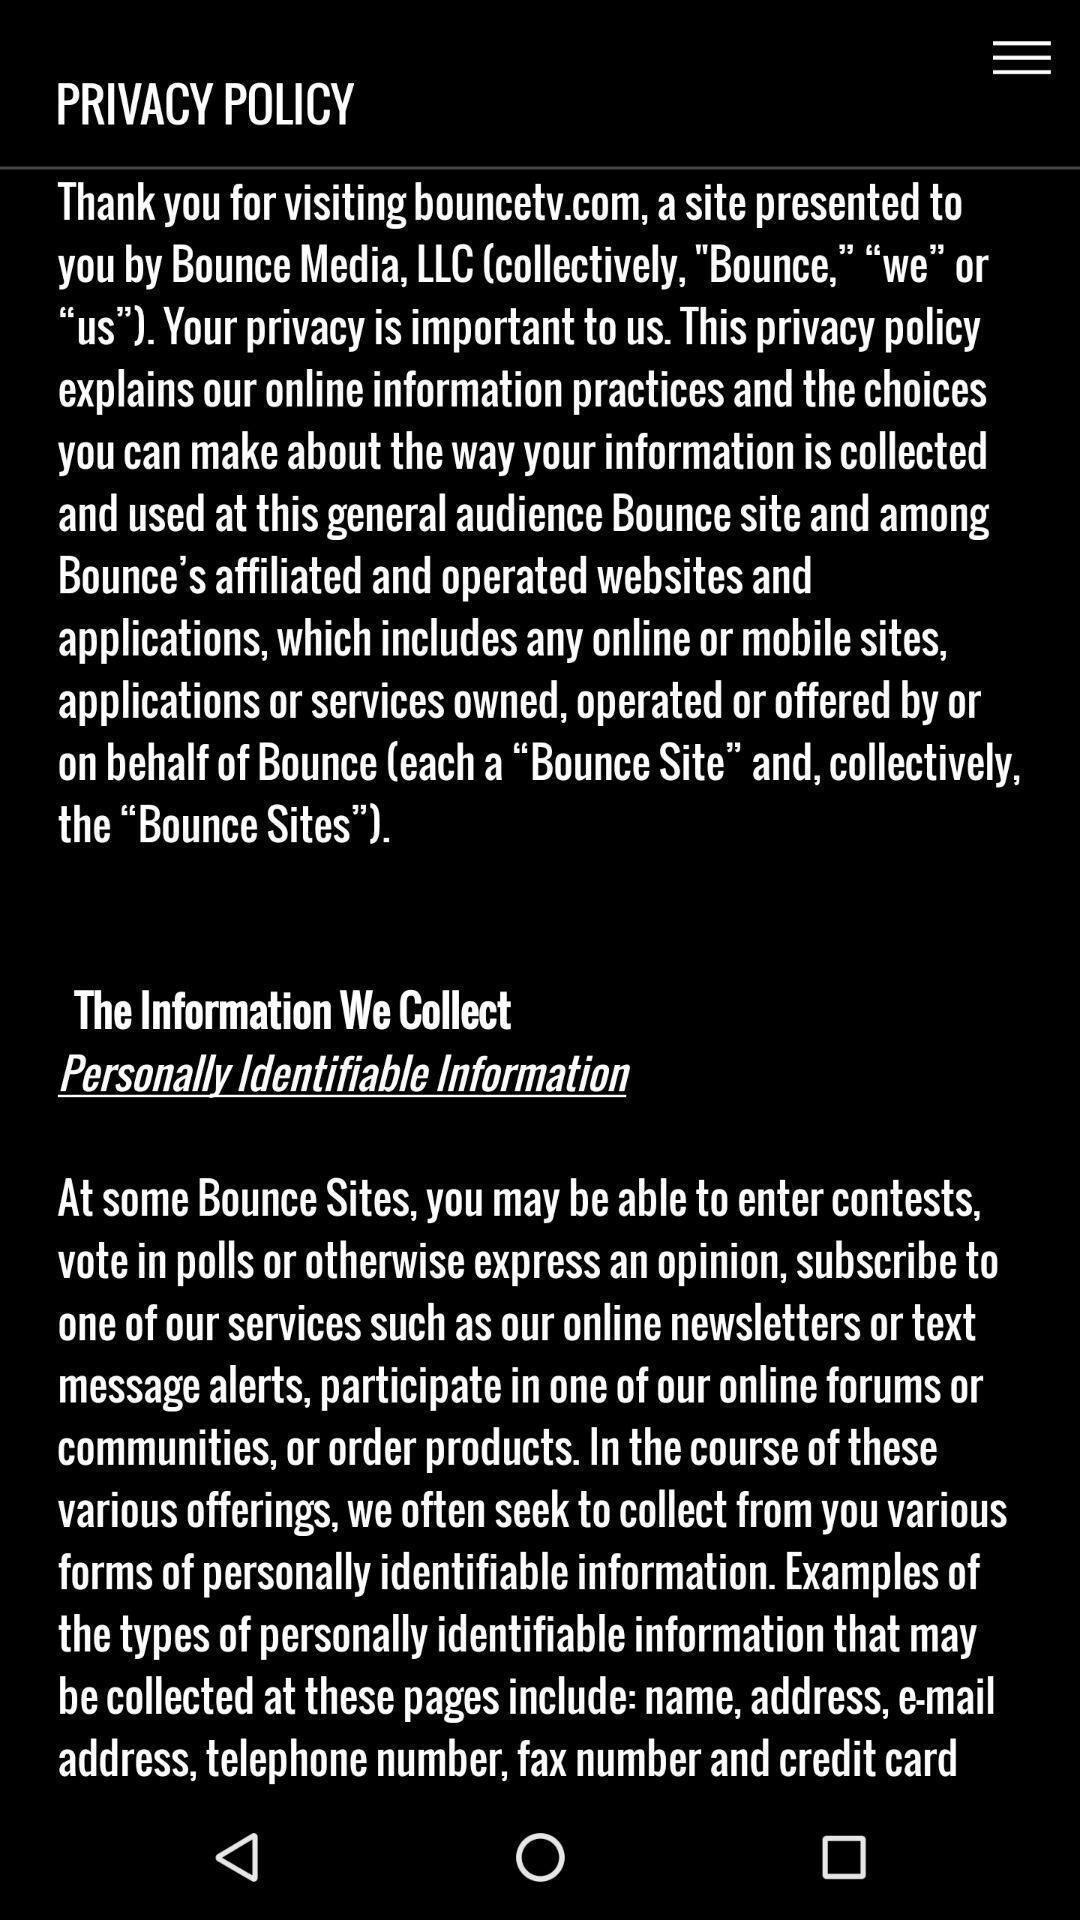Describe the key features of this screenshot. Screen displaying policies information of the application. 